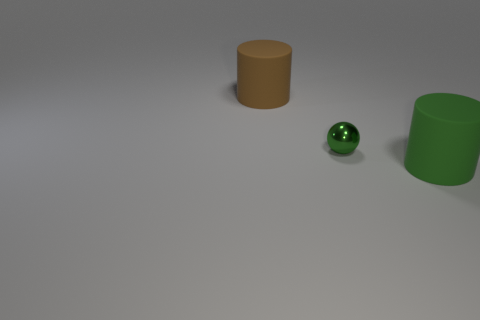Add 1 small brown shiny blocks. How many objects exist? 4 Subtract all spheres. How many objects are left? 2 Subtract 1 cylinders. How many cylinders are left? 1 Add 1 large brown cylinders. How many large brown cylinders are left? 2 Add 1 brown matte objects. How many brown matte objects exist? 2 Subtract 0 blue spheres. How many objects are left? 3 Subtract all cyan spheres. Subtract all blue blocks. How many spheres are left? 1 Subtract all brown cubes. How many green cylinders are left? 1 Subtract all brown rubber cylinders. Subtract all cylinders. How many objects are left? 0 